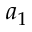<formula> <loc_0><loc_0><loc_500><loc_500>a _ { 1 }</formula> 